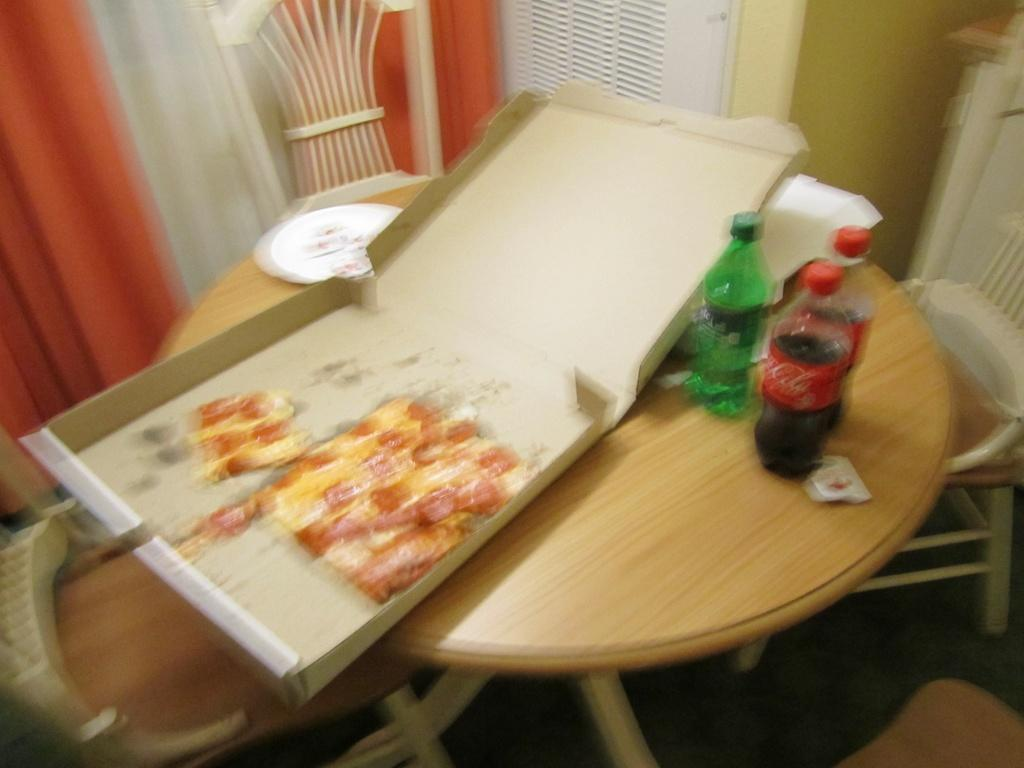What is present on the table in the image? There is food and bottles on the table in the image. What might people use to sit around the table? There are chairs around the table. Where is the hook located in the image? There is no hook present in the image. What type of nest can be seen on the table in the image? There is no nest present in the image. 